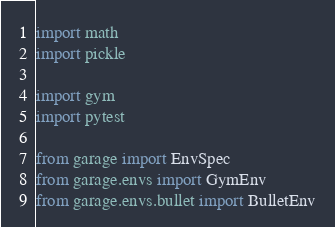Convert code to text. <code><loc_0><loc_0><loc_500><loc_500><_Python_>import math
import pickle

import gym
import pytest

from garage import EnvSpec
from garage.envs import GymEnv
from garage.envs.bullet import BulletEnv</code> 